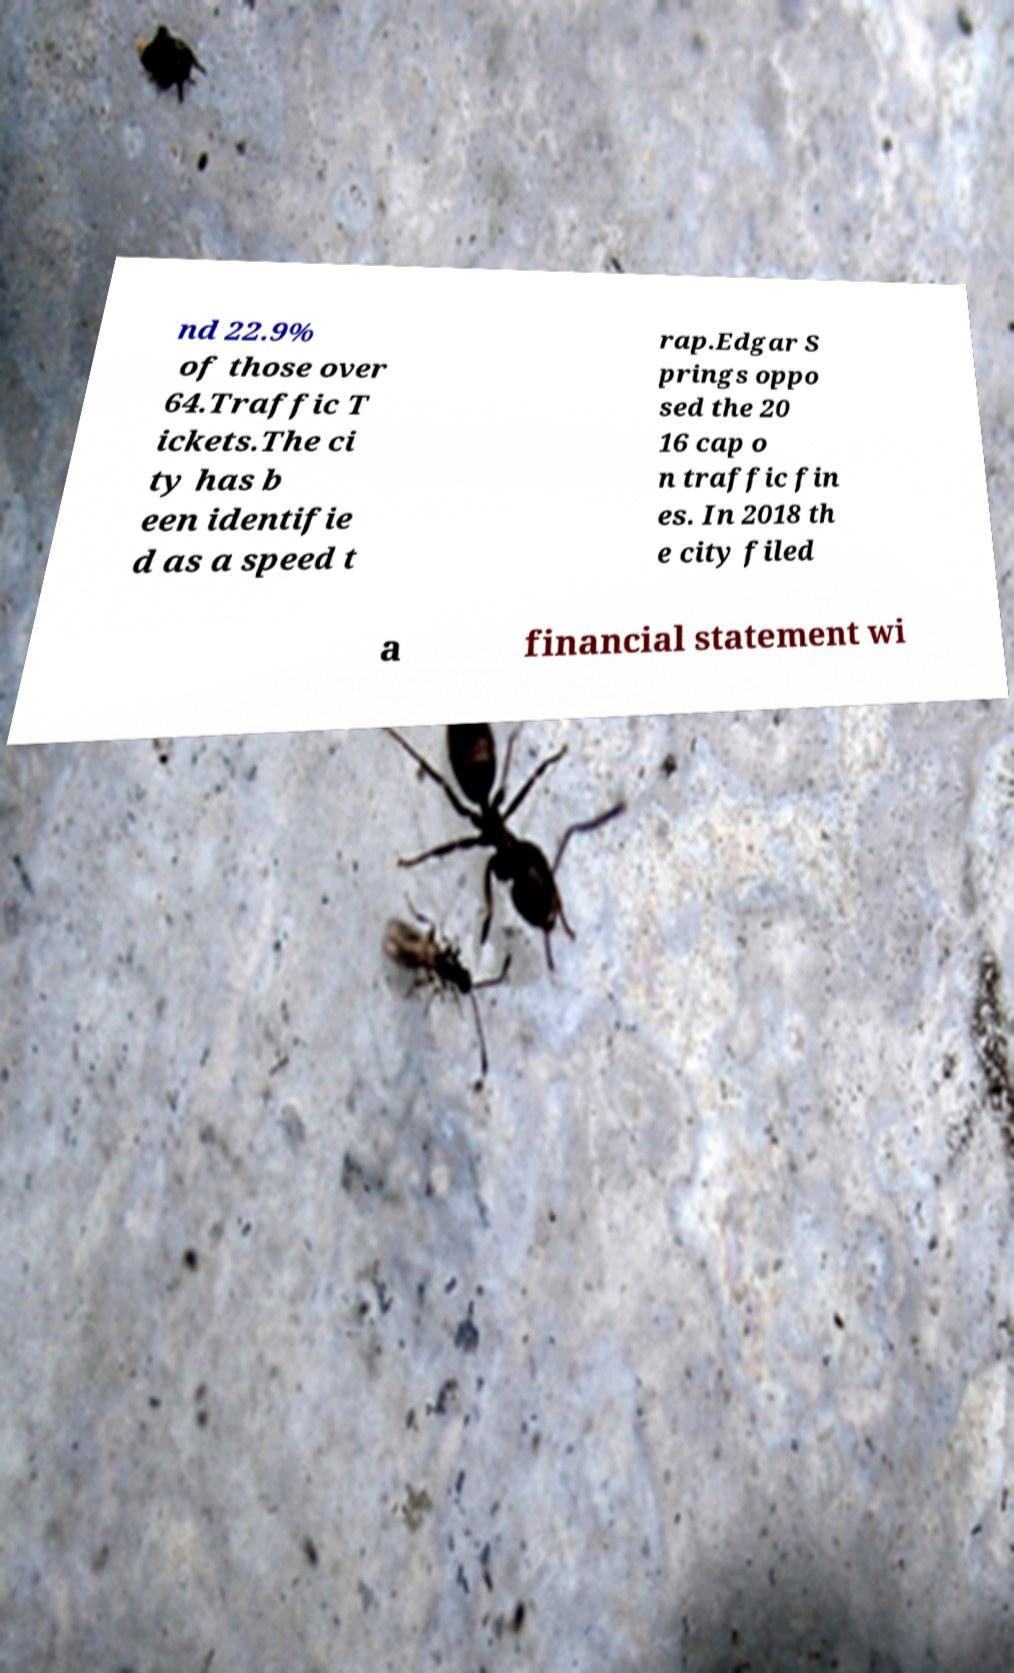Can you read and provide the text displayed in the image?This photo seems to have some interesting text. Can you extract and type it out for me? nd 22.9% of those over 64.Traffic T ickets.The ci ty has b een identifie d as a speed t rap.Edgar S prings oppo sed the 20 16 cap o n traffic fin es. In 2018 th e city filed a financial statement wi 